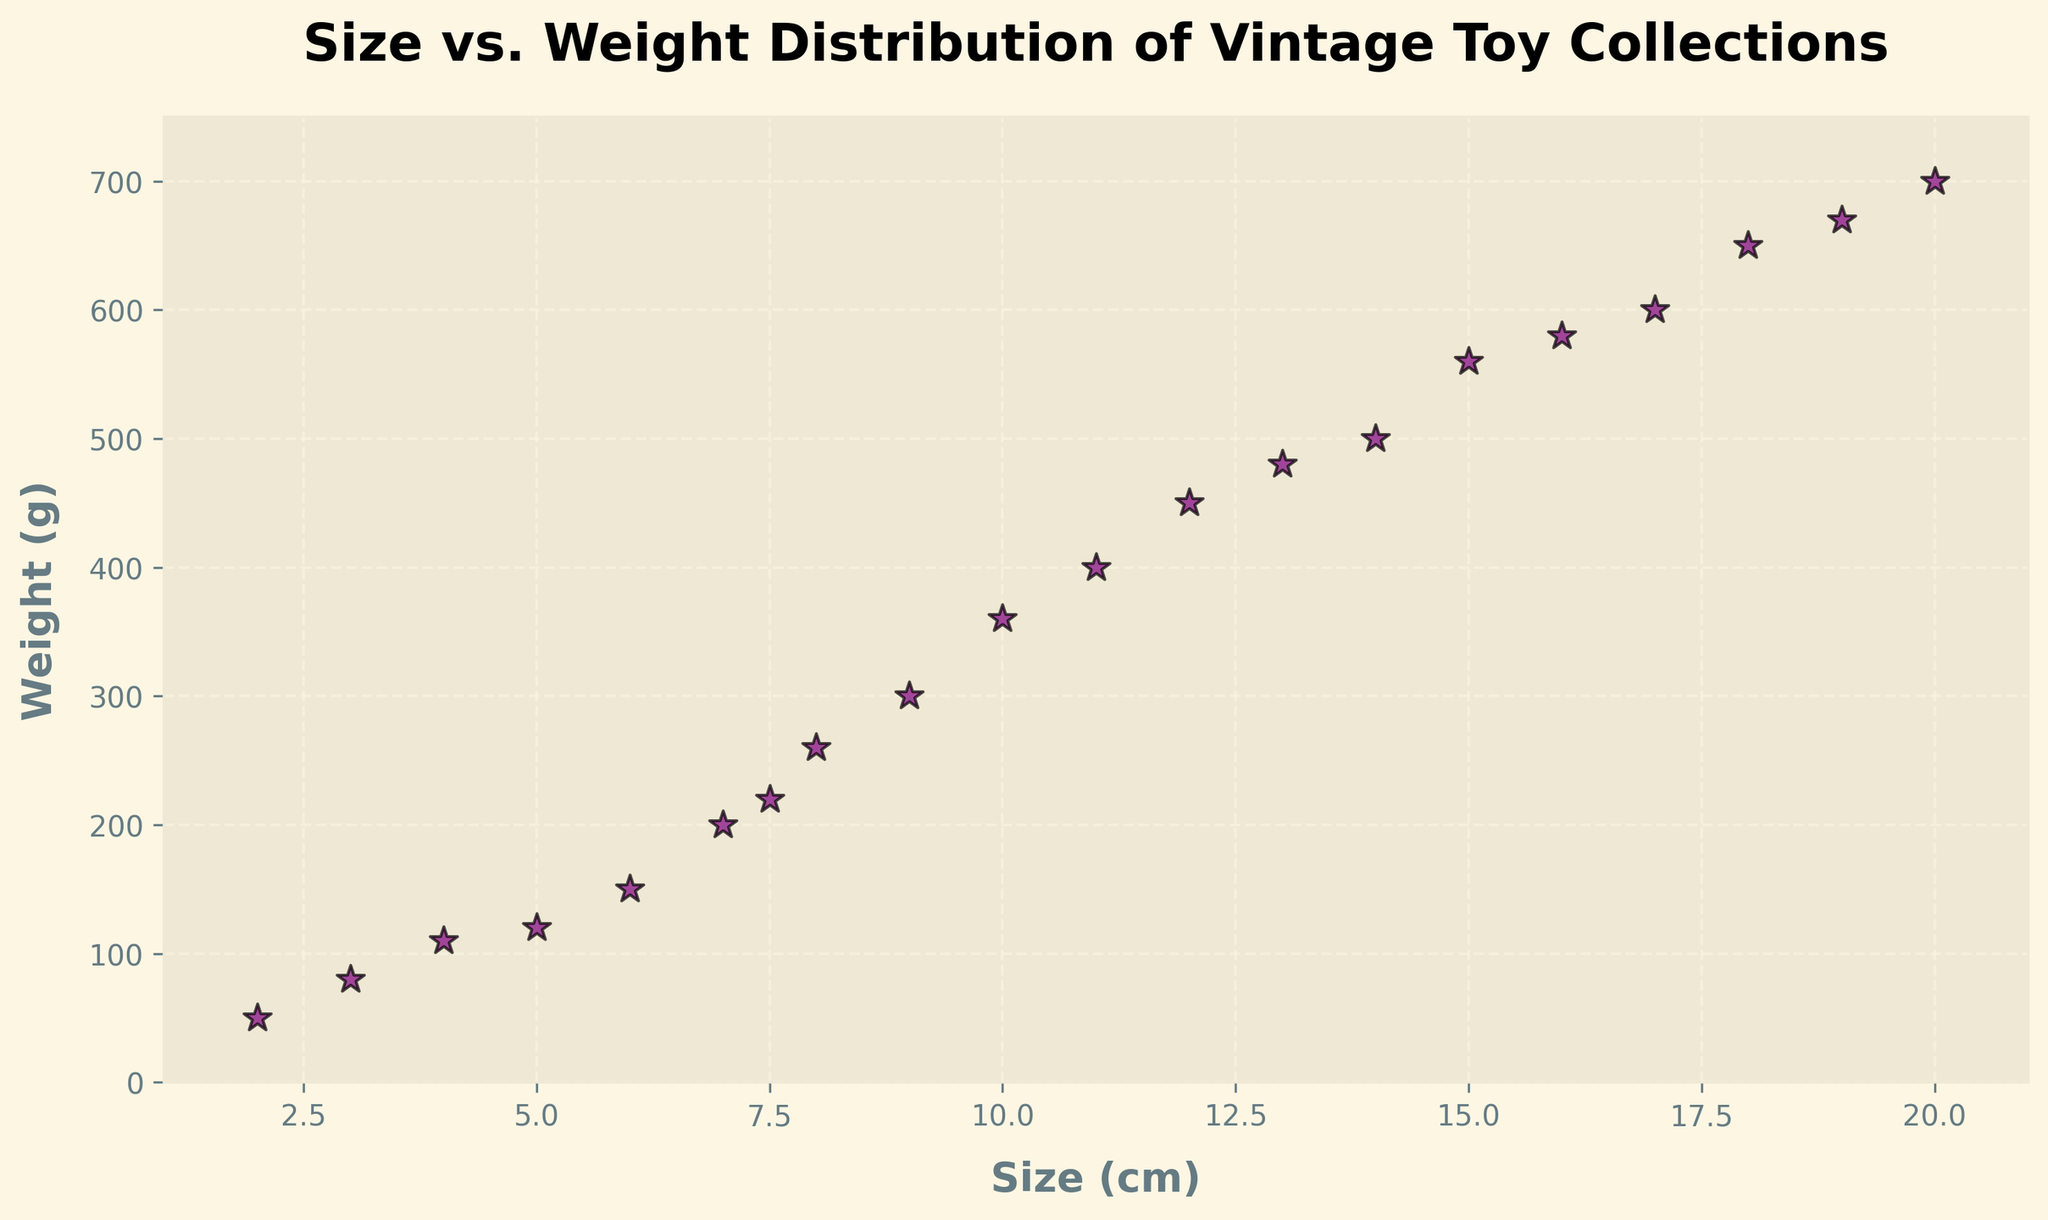What is the range of the weights of the vintage toy collection? To determine the range, subtract the smallest weight from the largest weight. The smallest weight is 50g, and the largest weight is 700g. The range is 700g - 50g.
Answer: 650g Which vintage toy has the largest size and what is its weight? Identify the toy with the largest size by inspecting the x-axis. The toy with the largest size is 20 cm. Its corresponding weight is 700g.
Answer: 700g How many vintage toys have a size greater than 15 cm? Count the data points on the x-axis with a size greater than 15 cm. The sizes greater than 15 cm are 16 cm, 17 cm, 18 cm, 19 cm, and 20 cm, so there are 5 toys in total.
Answer: 5 What is the average weight of the toys sized between 5 cm and 10 cm? Identify the toys with sizes between 5 cm and 10 cm (inclusive), then find their corresponding weights. The relevant weights are 120g, 200g, 150g, 360g, 300g, and 220g. Calculate the average by summing these weights and dividing by the count: (120+200+150+360+300+220)/6 = 1350/6.
Answer: 225g Which toy has a higher weight: the toy sized 12 cm or the toy sized 13 cm? Compare the weights of the toys sized 12 cm and 13 cm. The 12 cm toy weighs 450g, and the 13 cm toy weighs 480g. 480g is greater than 450g.
Answer: 13 cm How would you describe the trend in the relationship between size and weight for these toys? Observe the scatter plot for any noticeable patterns. Generally, as the size of the toys increases, their weights also tend to increase, showing a positive correlation between size and weight.
Answer: Positive correlation What is the median weight of the entire toy collection? To find the median, list all weights in ascending order and find the middle value. The weights are: 50, 80, 110, 120, 150, 200, 220, 260, 300, 360, 400, 450, 480, 500, 560, 580, 600, 650, 670, 700. The median is the average of the 10th and 11th values: (360+400)/2.
Answer: 380g Which toy size has the smallest corresponding weight? Inspect the figure for the smallest y-axis value and its corresponding x-axis value. The smallest weight is 50g, and the corresponding size is 2 cm.
Answer: 2 cm How many toys weigh more than 500 g, and what are their sizes? Count the data points on the y-axis with a weight greater than 500g. Identify their corresponding sizes. The toys weighing more than 500g are: 15 cm (560g), 16 cm (580g), 17 cm (600g), 18 cm (650g), 19 cm (670g), 20 cm (700g).
Answer: 6 toys Is there any toy with a size of exactly 7 cm? If so, what is its weight? Check the scatter plot for a data point at the x-axis value of 7 cm. There is indeed one, and its corresponding weight is 200g.
Answer: 200g 